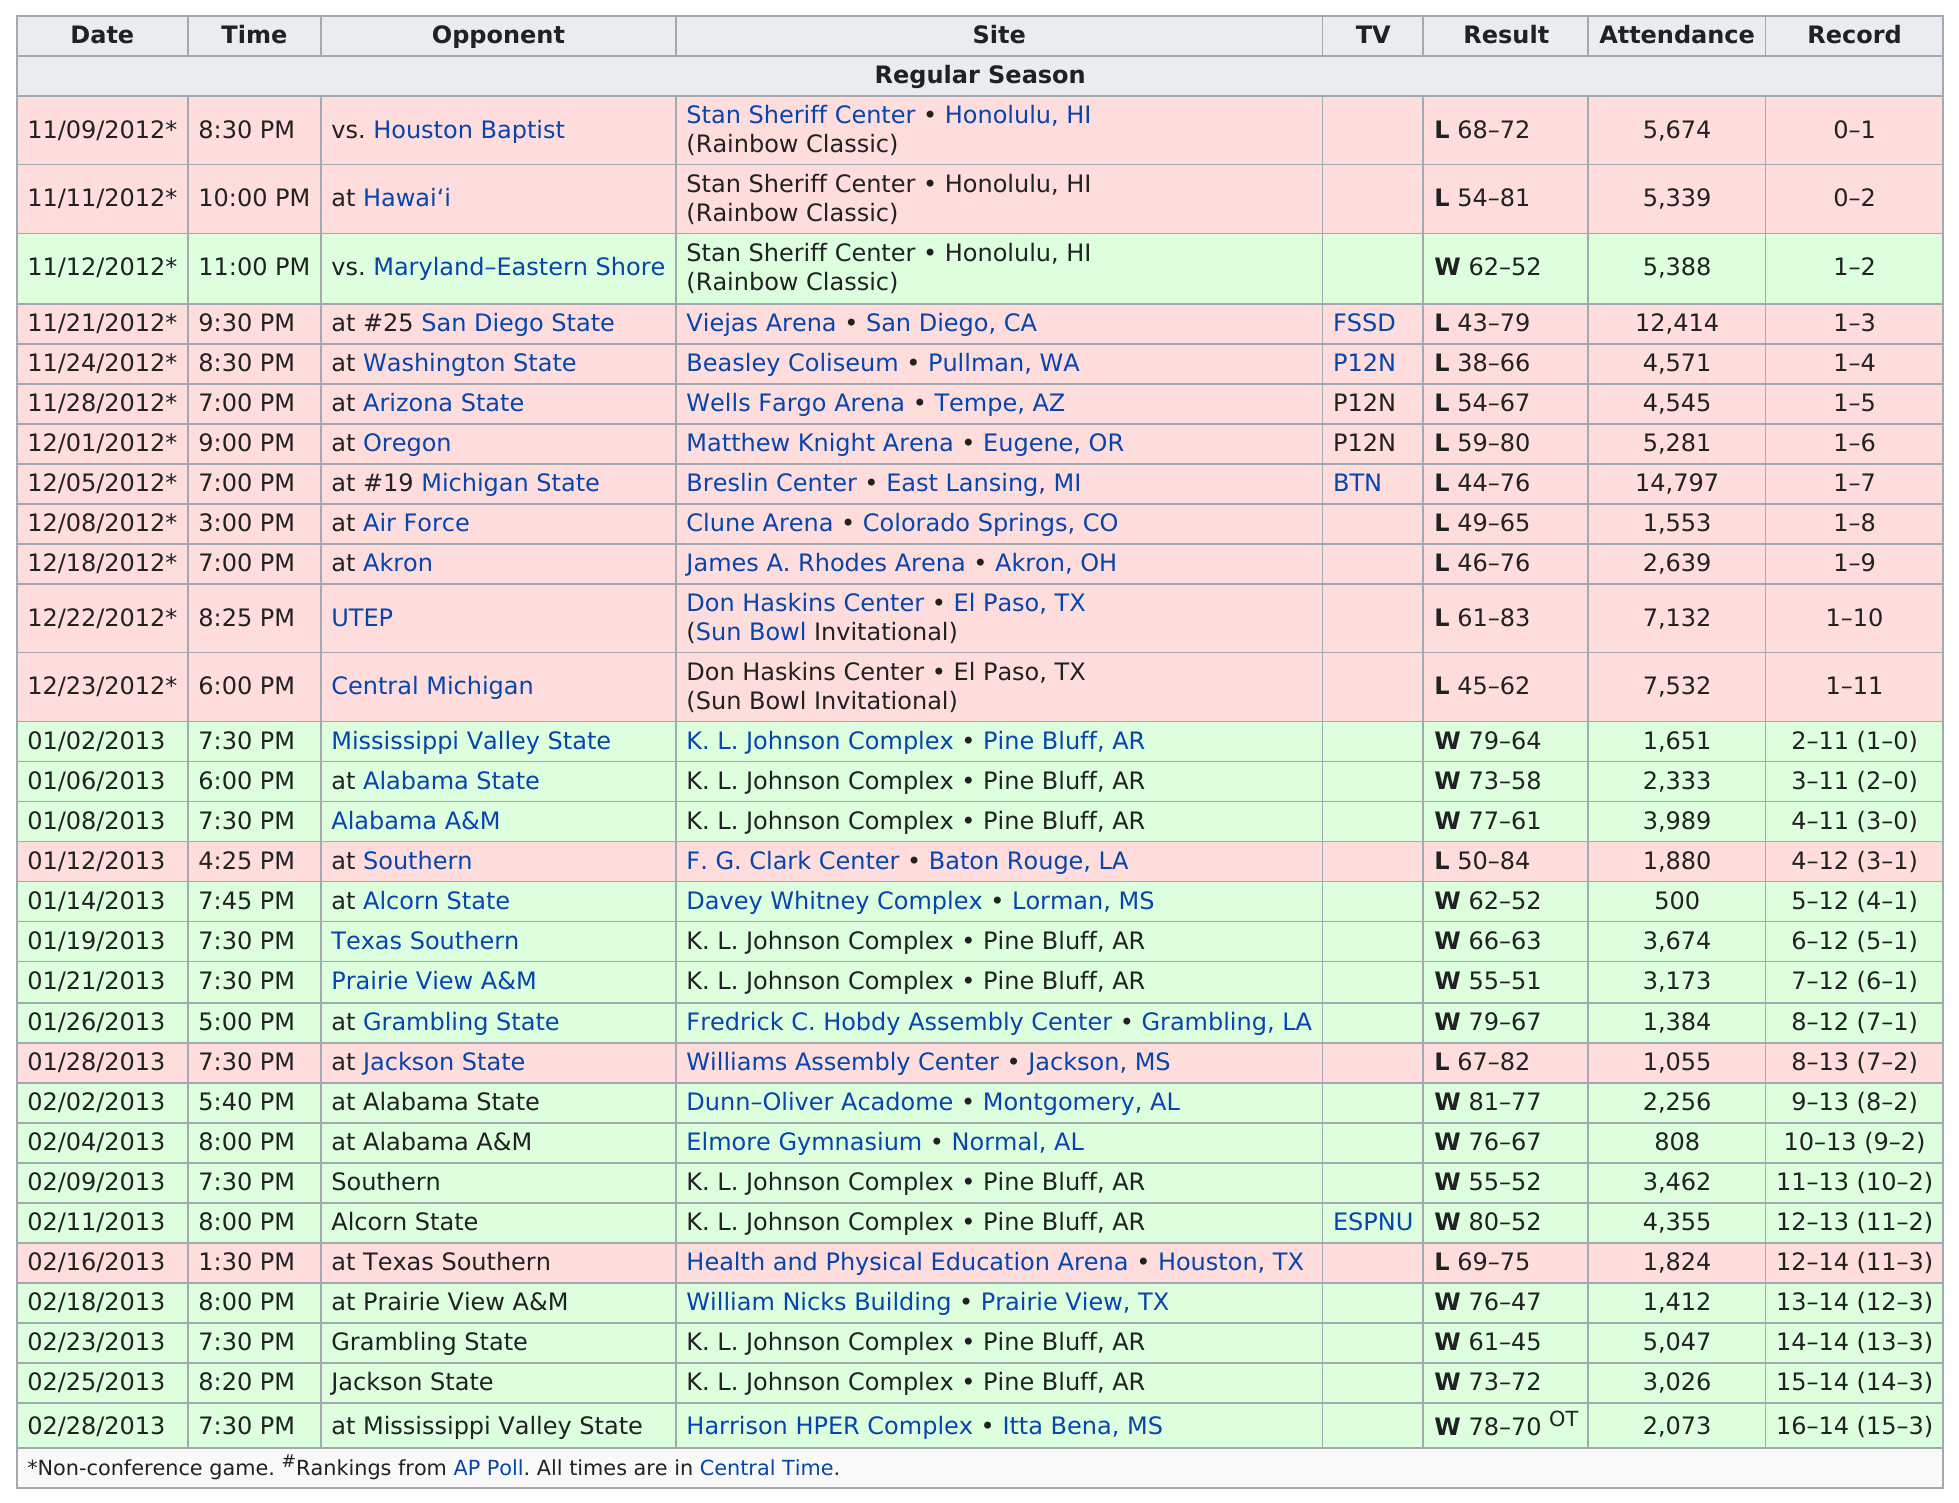Point out several critical features in this image. After playing against Hawai'i, the next opponent for Maryland-Eastern Shore will be their next opponent, Maryland-Eastern Shore. What date is at the very top?" refers to the question asked. In total, 16 wins were obtained. The total number of people who attended on 11/24/2012 was 4,571. On January 2, 2013, the first game that was won with a score over 70 points was played. 